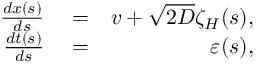<formula> <loc_0><loc_0><loc_500><loc_500>\begin{array} { r l r } { \frac { d x ( s ) } { d s } } & = } & { v + \sqrt { 2 D } \zeta _ { H } ( s ) , } \\ { \frac { d t ( s ) } { d s } } & = } & { \varepsilon ( s ) , } \end{array}</formula> 